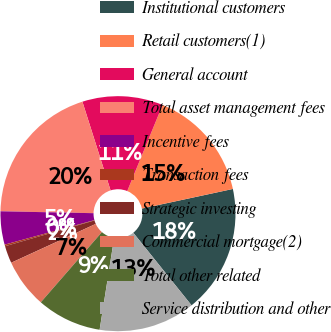Convert chart. <chart><loc_0><loc_0><loc_500><loc_500><pie_chart><fcel>Institutional customers<fcel>Retail customers(1)<fcel>General account<fcel>Total asset management fees<fcel>Incentive fees<fcel>Transaction fees<fcel>Strategic investing<fcel>Commercial mortgage(2)<fcel>Total other related<fcel>Service distribution and other<nl><fcel>17.61%<fcel>15.43%<fcel>11.09%<fcel>19.78%<fcel>4.57%<fcel>0.22%<fcel>2.39%<fcel>6.74%<fcel>8.91%<fcel>13.26%<nl></chart> 